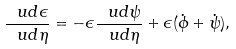Convert formula to latex. <formula><loc_0><loc_0><loc_500><loc_500>\frac { \ u d \epsilon } { \ u d \eta } = - \epsilon \frac { \ u d \psi } { \ u d \eta } + \epsilon ( \dot { \phi } + \dot { \psi } ) ,</formula> 